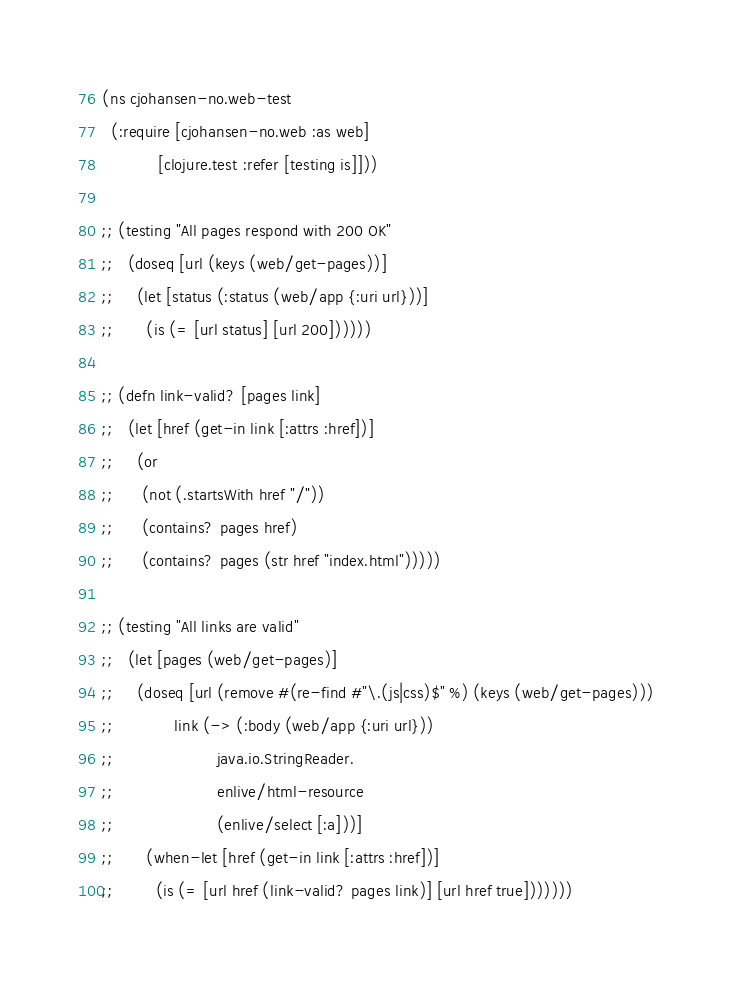Convert code to text. <code><loc_0><loc_0><loc_500><loc_500><_Clojure_>(ns cjohansen-no.web-test
  (:require [cjohansen-no.web :as web]
            [clojure.test :refer [testing is]]))

;; (testing "All pages respond with 200 OK"
;;   (doseq [url (keys (web/get-pages))]
;;     (let [status (:status (web/app {:uri url}))]
;;       (is (= [url status] [url 200])))))

;; (defn link-valid? [pages link]
;;   (let [href (get-in link [:attrs :href])]
;;     (or
;;      (not (.startsWith href "/"))
;;      (contains? pages href)
;;      (contains? pages (str href "index.html")))))

;; (testing "All links are valid"
;;   (let [pages (web/get-pages)]
;;     (doseq [url (remove #(re-find #"\.(js|css)$" %) (keys (web/get-pages)))
;;             link (-> (:body (web/app {:uri url}))
;;                      java.io.StringReader.
;;                      enlive/html-resource
;;                      (enlive/select [:a]))]
;;       (when-let [href (get-in link [:attrs :href])]
;;         (is (= [url href (link-valid? pages link)] [url href true]))))))
</code> 